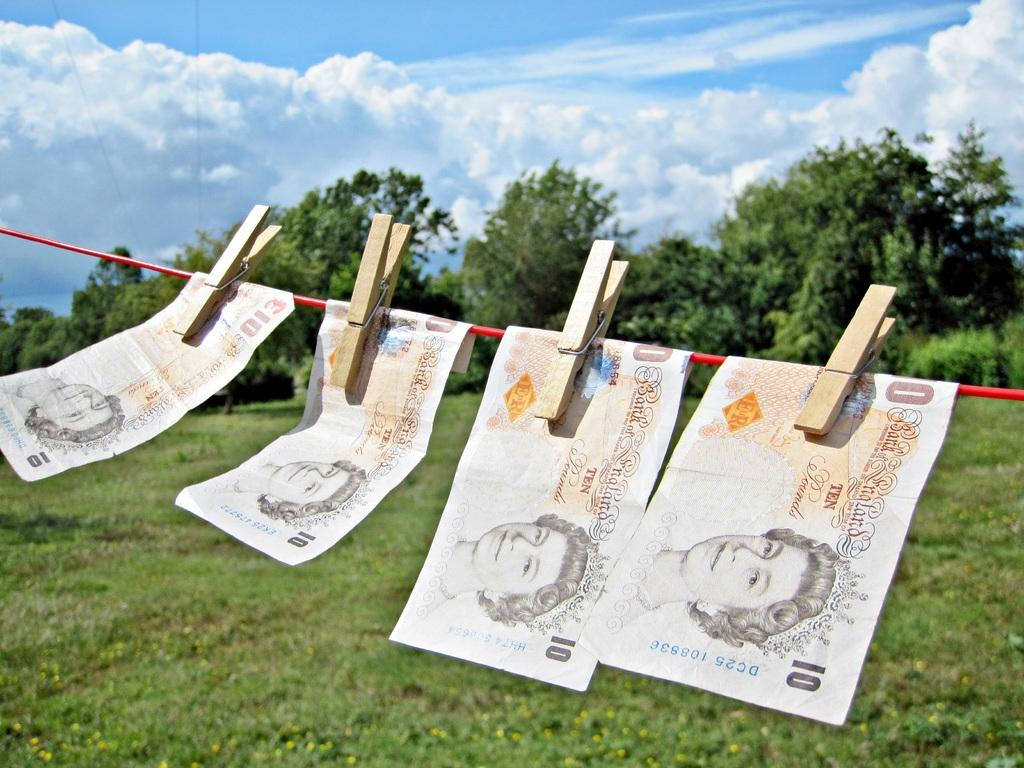<image>
Present a compact description of the photo's key features. Four 10 pound notes from the Bank of England are hanging outside on a string hung by clothespins 